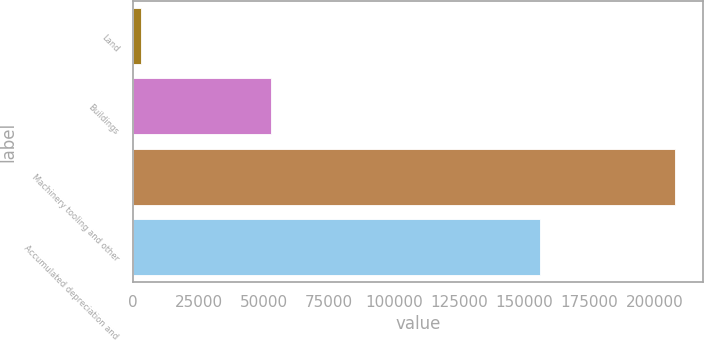<chart> <loc_0><loc_0><loc_500><loc_500><bar_chart><fcel>Land<fcel>Buildings<fcel>Machinery tooling and other<fcel>Accumulated depreciation and<nl><fcel>2936<fcel>52795<fcel>207906<fcel>156124<nl></chart> 